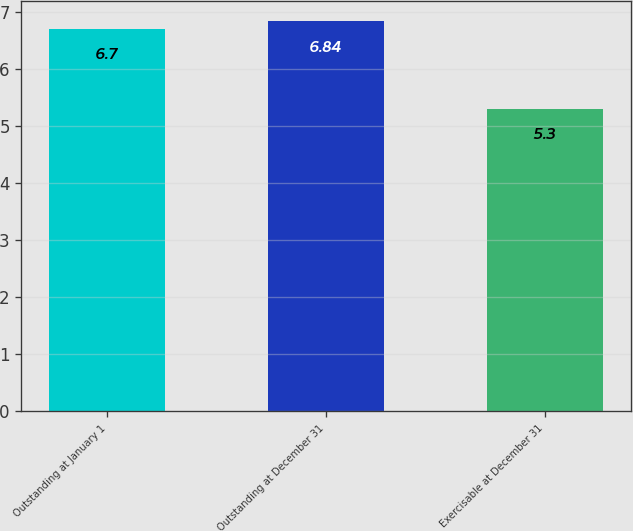Convert chart to OTSL. <chart><loc_0><loc_0><loc_500><loc_500><bar_chart><fcel>Outstanding at January 1<fcel>Outstanding at December 31<fcel>Exercisable at December 31<nl><fcel>6.7<fcel>6.84<fcel>5.3<nl></chart> 